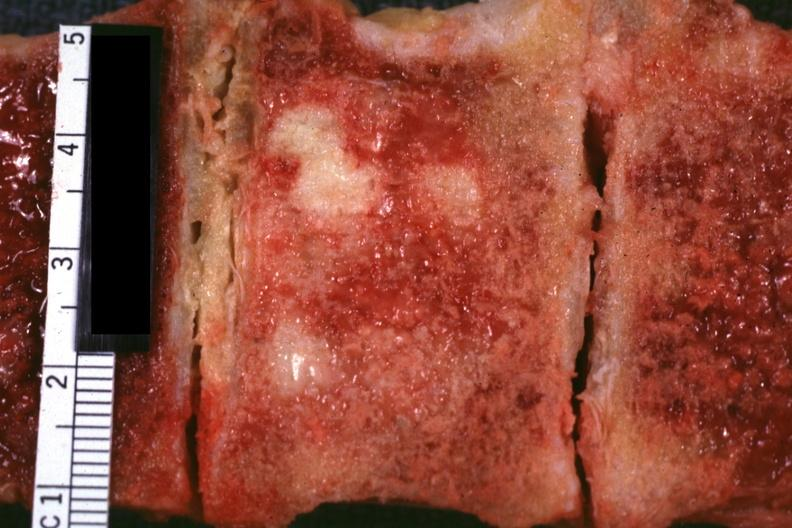what is prostate adenocarcinoma?
Answer the question using a single word or phrase. Excellent vertebral body primary 